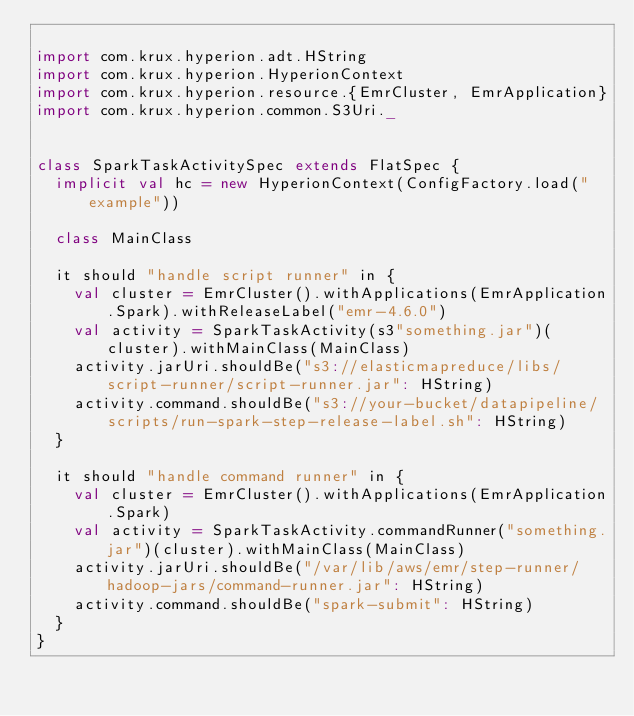<code> <loc_0><loc_0><loc_500><loc_500><_Scala_>
import com.krux.hyperion.adt.HString
import com.krux.hyperion.HyperionContext
import com.krux.hyperion.resource.{EmrCluster, EmrApplication}
import com.krux.hyperion.common.S3Uri._


class SparkTaskActivitySpec extends FlatSpec {
  implicit val hc = new HyperionContext(ConfigFactory.load("example"))

  class MainClass

  it should "handle script runner" in {
    val cluster = EmrCluster().withApplications(EmrApplication.Spark).withReleaseLabel("emr-4.6.0")
    val activity = SparkTaskActivity(s3"something.jar")(cluster).withMainClass(MainClass)
    activity.jarUri.shouldBe("s3://elasticmapreduce/libs/script-runner/script-runner.jar": HString)
    activity.command.shouldBe("s3://your-bucket/datapipeline/scripts/run-spark-step-release-label.sh": HString)
  }

  it should "handle command runner" in {
    val cluster = EmrCluster().withApplications(EmrApplication.Spark)
    val activity = SparkTaskActivity.commandRunner("something.jar")(cluster).withMainClass(MainClass)
    activity.jarUri.shouldBe("/var/lib/aws/emr/step-runner/hadoop-jars/command-runner.jar": HString)
    activity.command.shouldBe("spark-submit": HString)
  }
}
</code> 